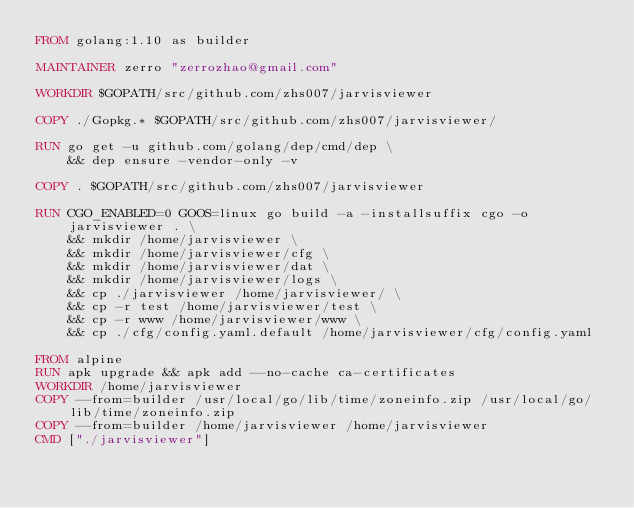Convert code to text. <code><loc_0><loc_0><loc_500><loc_500><_Dockerfile_>FROM golang:1.10 as builder

MAINTAINER zerro "zerrozhao@gmail.com"

WORKDIR $GOPATH/src/github.com/zhs007/jarvisviewer

COPY ./Gopkg.* $GOPATH/src/github.com/zhs007/jarvisviewer/

RUN go get -u github.com/golang/dep/cmd/dep \
    && dep ensure -vendor-only -v

COPY . $GOPATH/src/github.com/zhs007/jarvisviewer

RUN CGO_ENABLED=0 GOOS=linux go build -a -installsuffix cgo -o jarvisviewer . \
    && mkdir /home/jarvisviewer \
    && mkdir /home/jarvisviewer/cfg \
    && mkdir /home/jarvisviewer/dat \
    && mkdir /home/jarvisviewer/logs \
    && cp ./jarvisviewer /home/jarvisviewer/ \
    && cp -r test /home/jarvisviewer/test \
    && cp -r www /home/jarvisviewer/www \
    && cp ./cfg/config.yaml.default /home/jarvisviewer/cfg/config.yaml

FROM alpine
RUN apk upgrade && apk add --no-cache ca-certificates
WORKDIR /home/jarvisviewer
COPY --from=builder /usr/local/go/lib/time/zoneinfo.zip /usr/local/go/lib/time/zoneinfo.zip
COPY --from=builder /home/jarvisviewer /home/jarvisviewer
CMD ["./jarvisviewer"]
</code> 